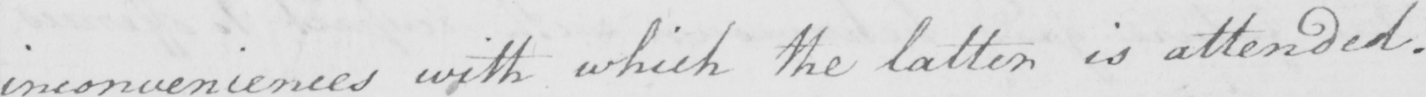Please provide the text content of this handwritten line. inconveniences with which the latter is attended . 